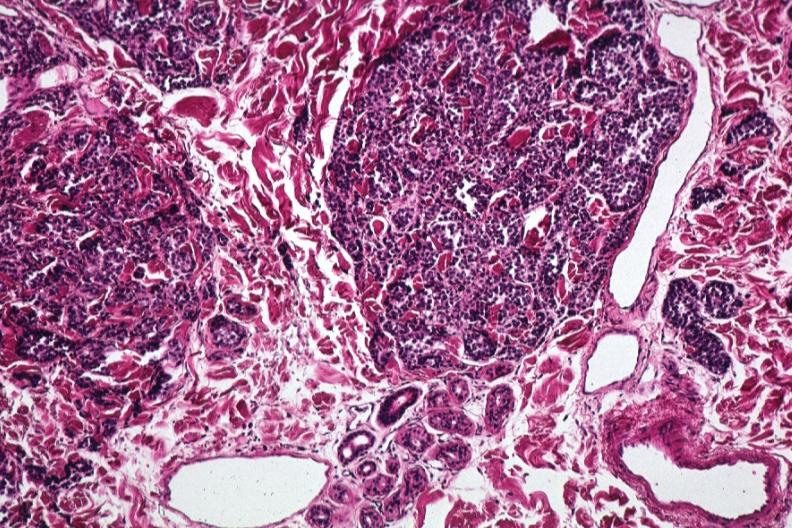s all the fat necrosis present?
Answer the question using a single word or phrase. No 